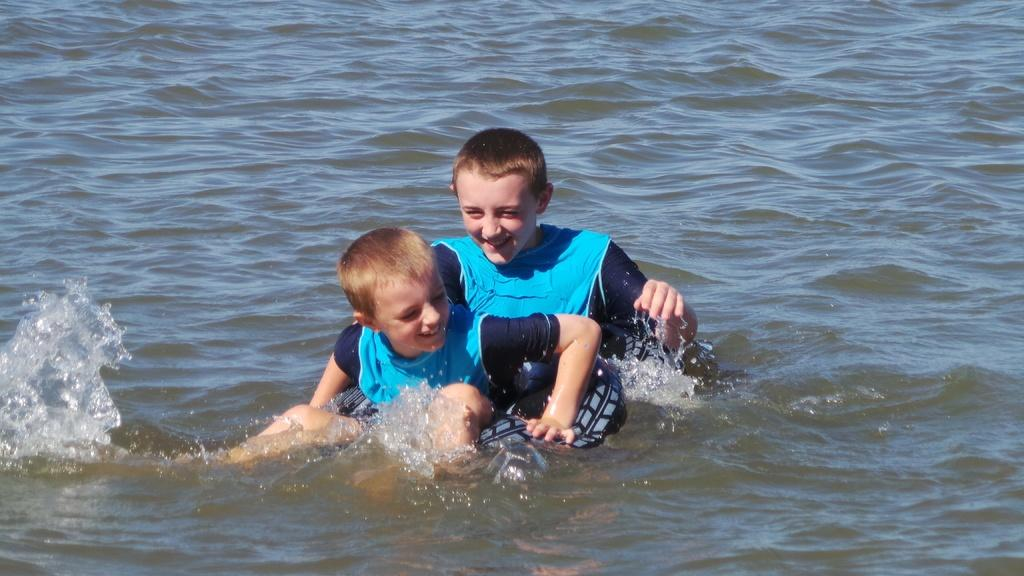Who is present in the image? There are kids in the image. What are the kids doing in the image? The kids are playing in the water. What type of pail is being used by the kids to care for their loss in the image? There is no pail or loss mentioned in the image; it simply shows kids playing in the water. 